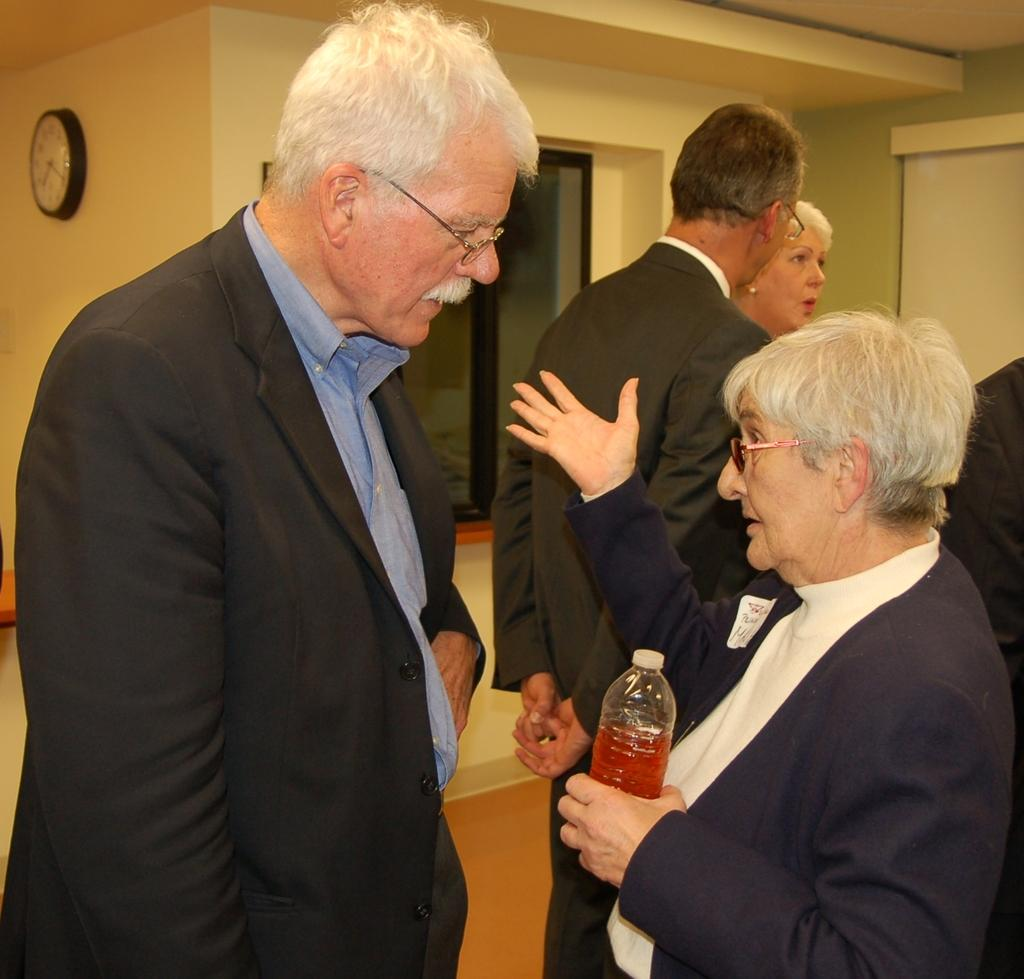What are the people in the image doing? The people in the image are standing. Can you describe what one person is holding? One person is holding a juice bottle. What can be seen on the wall in the image? There is a clock on the wall. What type of clothing are the people wearing? All the people in the image are wearing suits. Is there a jail visible in the image? No, there is no jail present in the image. Can you see a lake in the background of the image? No, there is no lake visible in the image. 